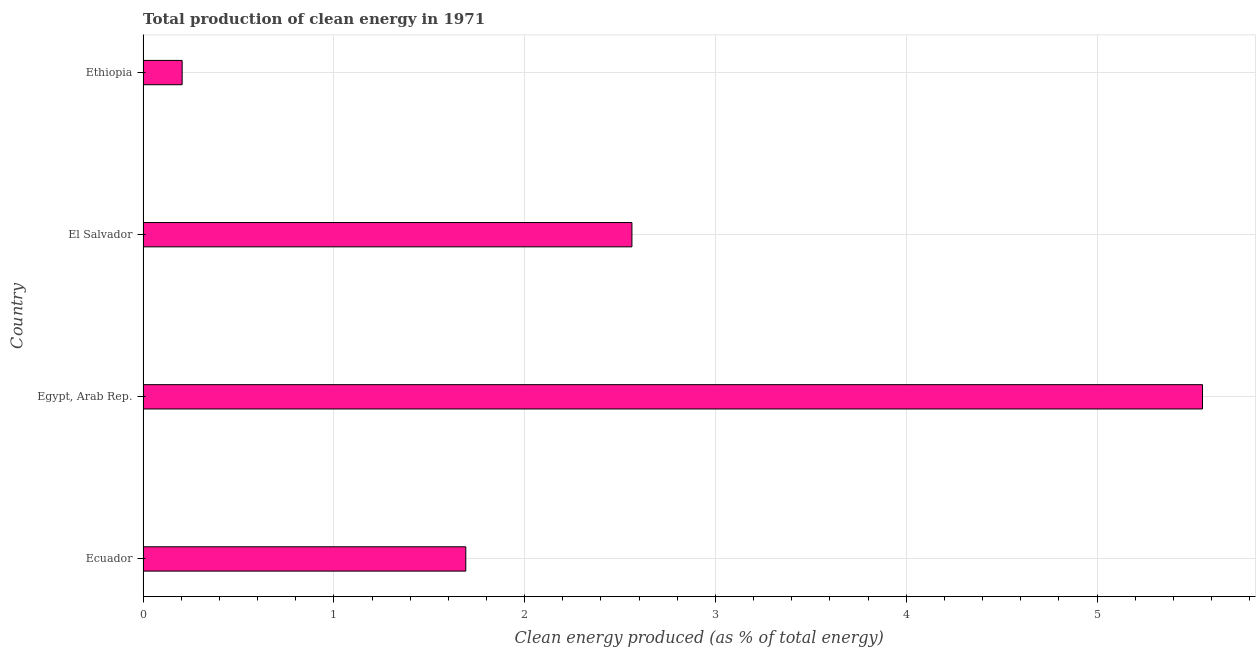What is the title of the graph?
Provide a short and direct response. Total production of clean energy in 1971. What is the label or title of the X-axis?
Offer a terse response. Clean energy produced (as % of total energy). What is the label or title of the Y-axis?
Give a very brief answer. Country. What is the production of clean energy in El Salvador?
Your answer should be compact. 2.56. Across all countries, what is the maximum production of clean energy?
Provide a short and direct response. 5.55. Across all countries, what is the minimum production of clean energy?
Your answer should be compact. 0.2. In which country was the production of clean energy maximum?
Make the answer very short. Egypt, Arab Rep. In which country was the production of clean energy minimum?
Ensure brevity in your answer.  Ethiopia. What is the sum of the production of clean energy?
Keep it short and to the point. 10.01. What is the difference between the production of clean energy in Ecuador and Ethiopia?
Offer a very short reply. 1.49. What is the average production of clean energy per country?
Give a very brief answer. 2.5. What is the median production of clean energy?
Keep it short and to the point. 2.13. In how many countries, is the production of clean energy greater than 0.4 %?
Provide a short and direct response. 3. What is the ratio of the production of clean energy in Ecuador to that in Ethiopia?
Offer a very short reply. 8.26. Is the difference between the production of clean energy in Ecuador and Egypt, Arab Rep. greater than the difference between any two countries?
Make the answer very short. No. What is the difference between the highest and the second highest production of clean energy?
Your answer should be compact. 2.99. Is the sum of the production of clean energy in El Salvador and Ethiopia greater than the maximum production of clean energy across all countries?
Your answer should be very brief. No. What is the difference between the highest and the lowest production of clean energy?
Give a very brief answer. 5.35. In how many countries, is the production of clean energy greater than the average production of clean energy taken over all countries?
Ensure brevity in your answer.  2. How many bars are there?
Make the answer very short. 4. Are all the bars in the graph horizontal?
Keep it short and to the point. Yes. What is the difference between two consecutive major ticks on the X-axis?
Ensure brevity in your answer.  1. What is the Clean energy produced (as % of total energy) of Ecuador?
Offer a very short reply. 1.69. What is the Clean energy produced (as % of total energy) of Egypt, Arab Rep.?
Make the answer very short. 5.55. What is the Clean energy produced (as % of total energy) of El Salvador?
Provide a succinct answer. 2.56. What is the Clean energy produced (as % of total energy) of Ethiopia?
Offer a very short reply. 0.2. What is the difference between the Clean energy produced (as % of total energy) in Ecuador and Egypt, Arab Rep.?
Keep it short and to the point. -3.86. What is the difference between the Clean energy produced (as % of total energy) in Ecuador and El Salvador?
Make the answer very short. -0.87. What is the difference between the Clean energy produced (as % of total energy) in Ecuador and Ethiopia?
Offer a terse response. 1.49. What is the difference between the Clean energy produced (as % of total energy) in Egypt, Arab Rep. and El Salvador?
Provide a short and direct response. 2.99. What is the difference between the Clean energy produced (as % of total energy) in Egypt, Arab Rep. and Ethiopia?
Offer a very short reply. 5.35. What is the difference between the Clean energy produced (as % of total energy) in El Salvador and Ethiopia?
Offer a terse response. 2.36. What is the ratio of the Clean energy produced (as % of total energy) in Ecuador to that in Egypt, Arab Rep.?
Your response must be concise. 0.3. What is the ratio of the Clean energy produced (as % of total energy) in Ecuador to that in El Salvador?
Ensure brevity in your answer.  0.66. What is the ratio of the Clean energy produced (as % of total energy) in Ecuador to that in Ethiopia?
Offer a very short reply. 8.26. What is the ratio of the Clean energy produced (as % of total energy) in Egypt, Arab Rep. to that in El Salvador?
Offer a very short reply. 2.17. What is the ratio of the Clean energy produced (as % of total energy) in Egypt, Arab Rep. to that in Ethiopia?
Provide a short and direct response. 27.12. What is the ratio of the Clean energy produced (as % of total energy) in El Salvador to that in Ethiopia?
Provide a succinct answer. 12.51. 